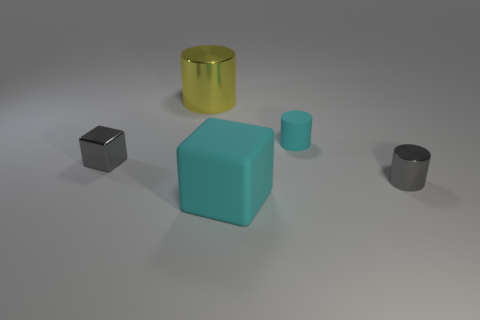Add 4 tiny cyan cylinders. How many objects exist? 9 Subtract all blocks. How many objects are left? 3 Subtract 0 red cubes. How many objects are left? 5 Subtract all small metallic cylinders. Subtract all cyan rubber objects. How many objects are left? 2 Add 4 cyan things. How many cyan things are left? 6 Add 4 cyan rubber cylinders. How many cyan rubber cylinders exist? 5 